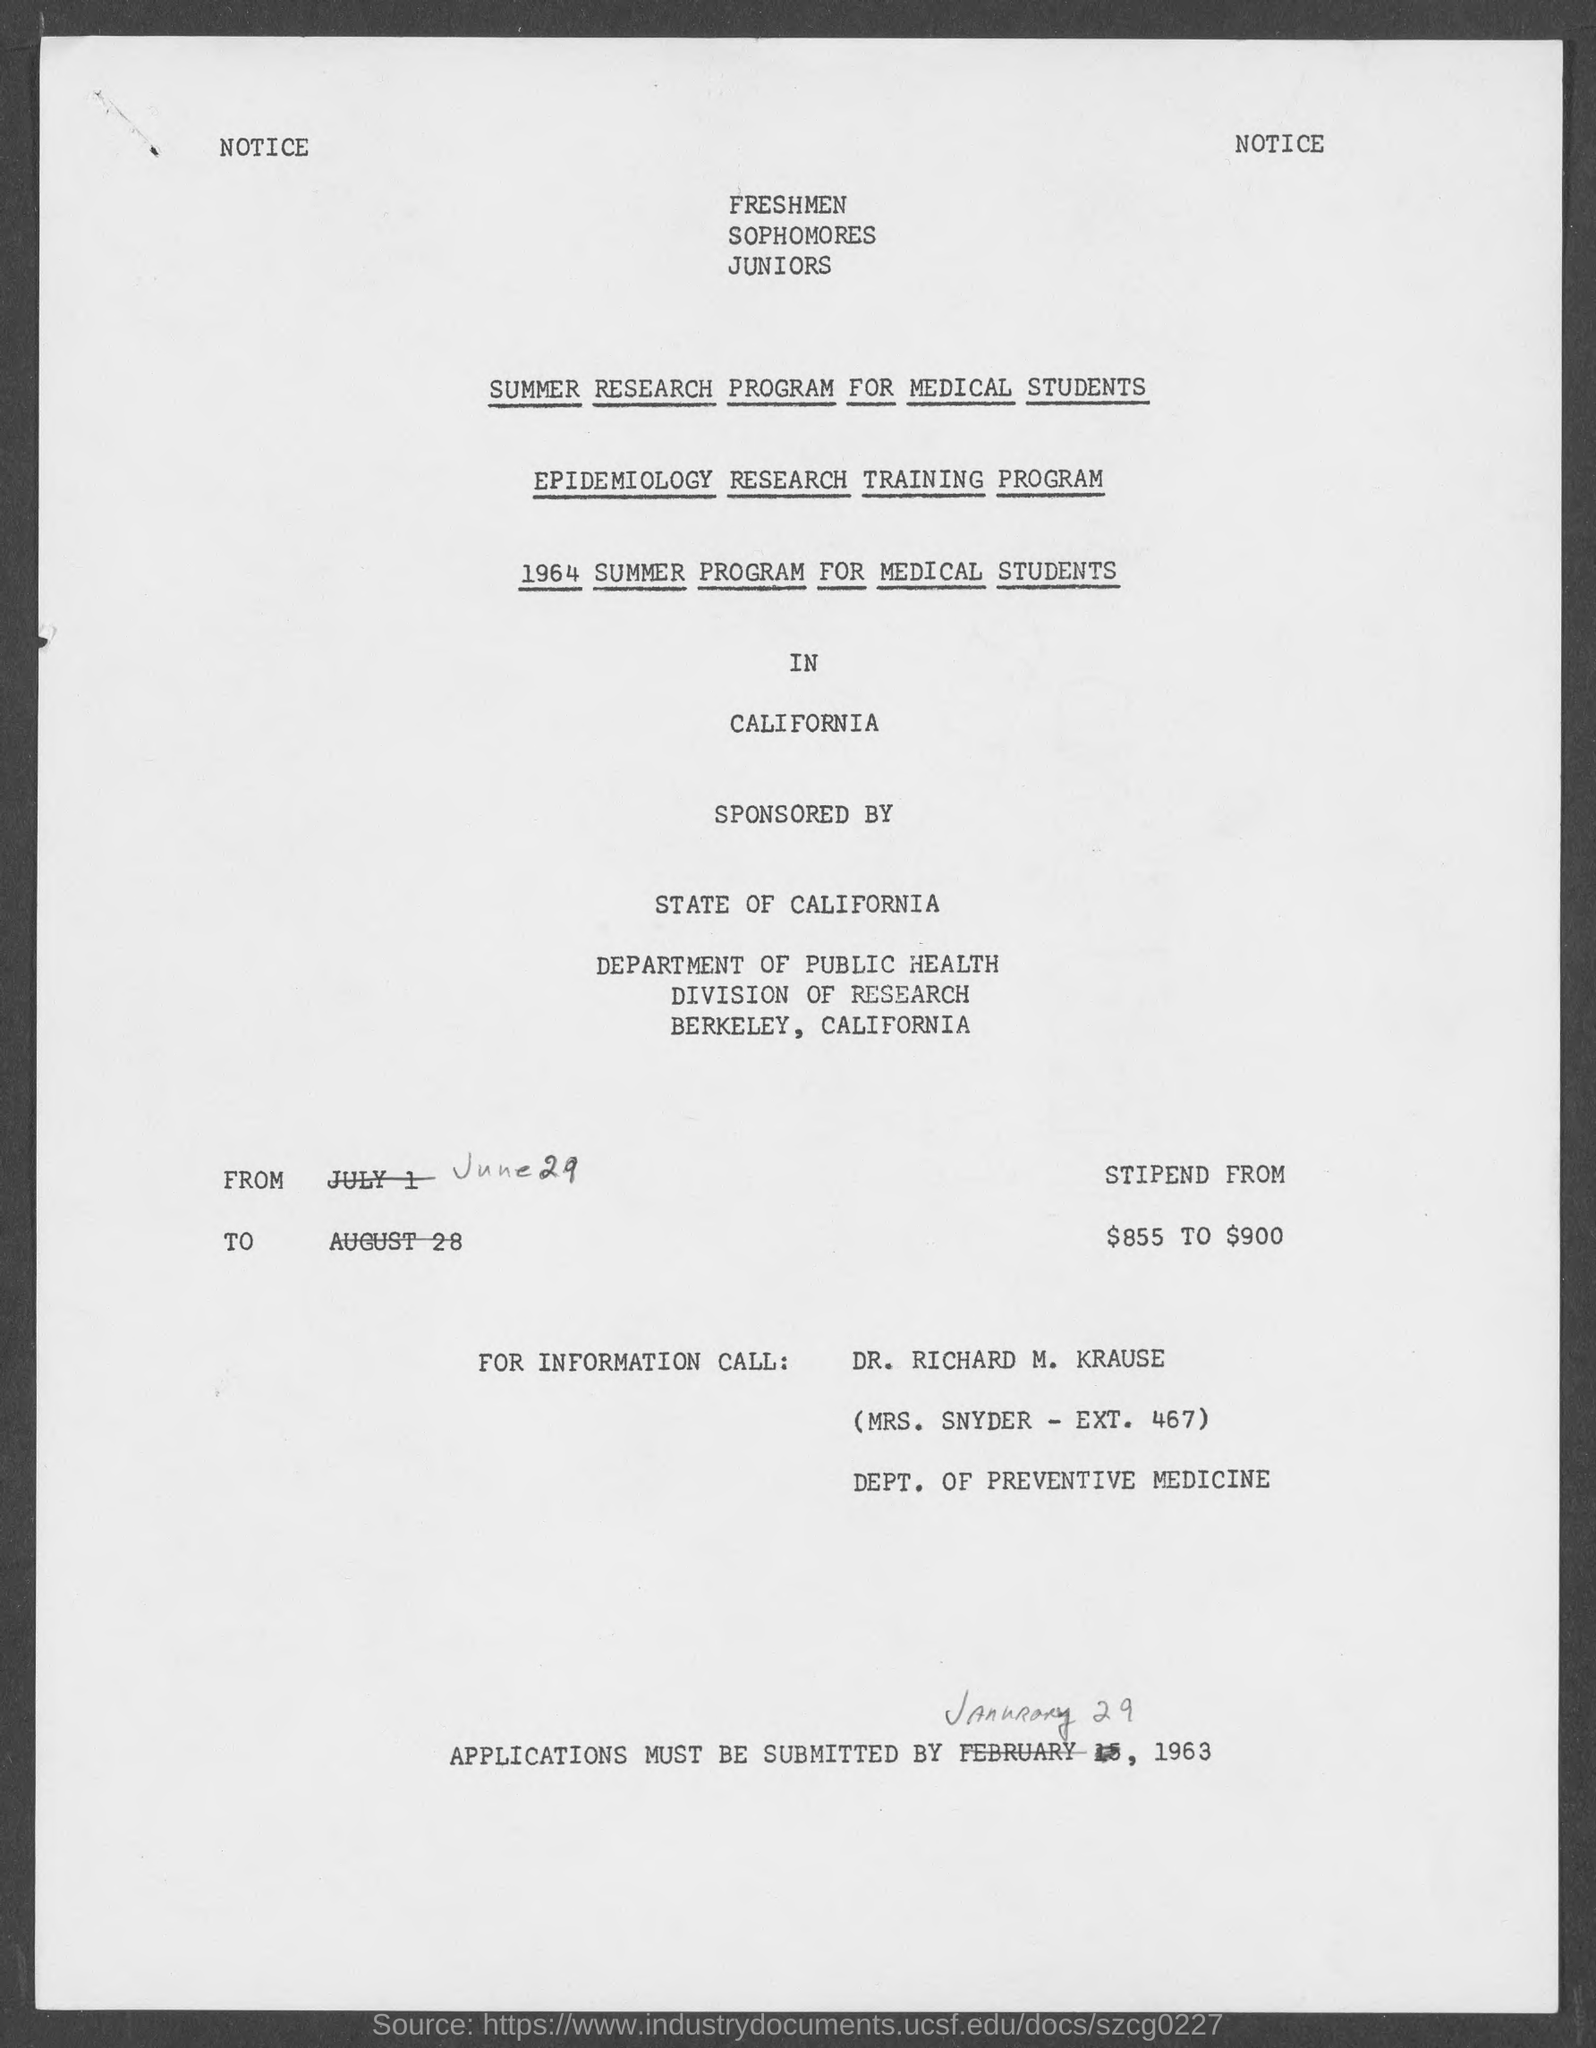List a handful of essential elements in this visual. It is necessary that applications be submitted by January 29, 1963. The stipend ranges from $855 to $900. 